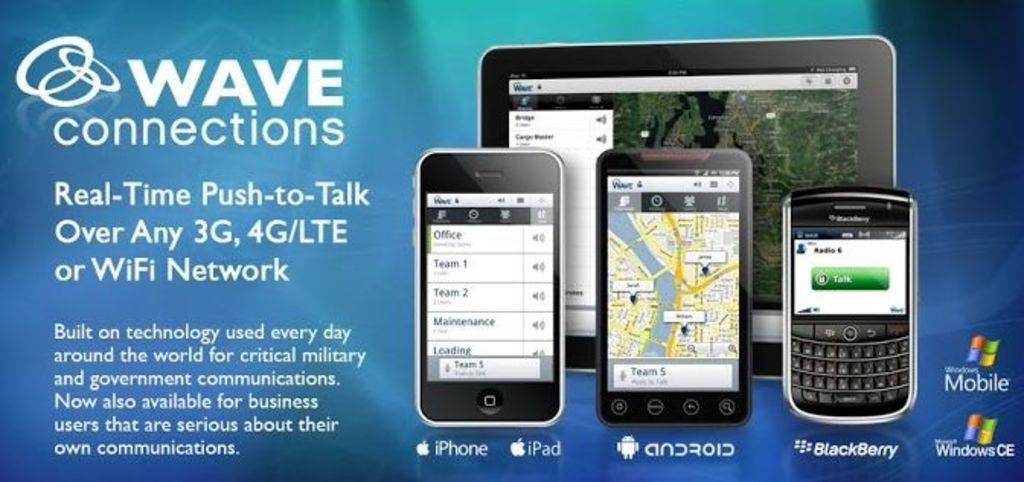<image>
Relay a brief, clear account of the picture shown. Advertisement for Wave Connections showing their new phones to buy. 